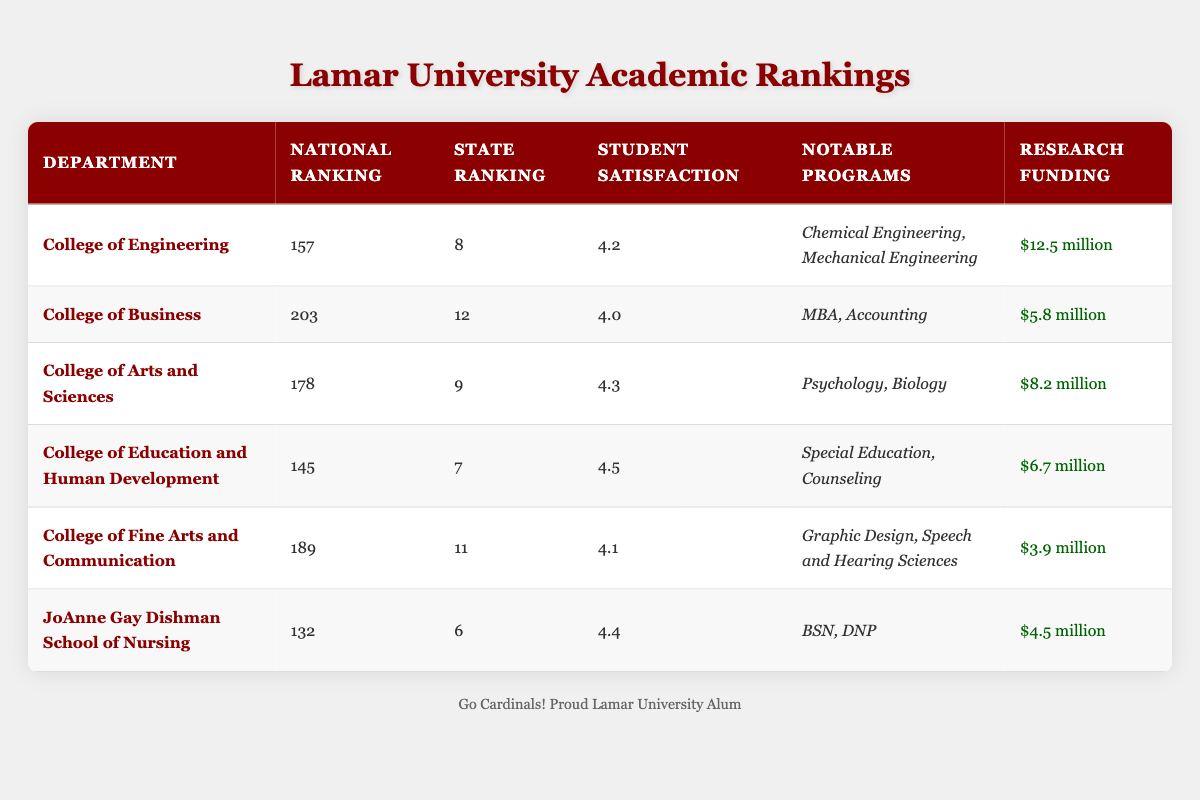What is the national ranking of the College of Engineering? The national ranking of the College of Engineering is 157, as listed in the table.
Answer: 157 Which department has the highest student satisfaction rating? The College of Education and Human Development has the highest student satisfaction rating of 4.5.
Answer: 4.5 What is the average state ranking of all departments? To find the average state ranking, add all state rankings (8 + 12 + 9 + 7 + 11 + 6 = 53) and divide by the number of departments (6), which gives 53/6 = 8.83.
Answer: 8.83 Is the research funding for the College of Fine Arts and Communication more than $4 million? The research funding for the College of Fine Arts and Communication is $3.9 million, which is less than $4 million.
Answer: No Which department has the lowest national ranking and what is it? The department with the lowest national ranking is the College of Business with a ranking of 203.
Answer: 203 How much more research funding does the College of Engineering have compared to the JoAnne Gay Dishman School of Nursing? The College of Engineering has $12.5 million and the JoAnne Gay Dishman School of Nursing has $4.5 million. The difference is 12.5 - 4.5 = $8 million.
Answer: $8 million Are there more notable programs in the College of Arts and Sciences compared to the College of Business? The College of Arts and Sciences has 2 notable programs (Psychology, Biology) and the College of Business also has 2 notable programs (MBA, Accounting), so they have the same number.
Answer: No What is the student satisfaction rating of the JoAnne Gay Dishman School of Nursing? The student satisfaction rating for the JoAnne Gay Dishman School of Nursing is 4.4, as shown in the table.
Answer: 4.4 Which department is ranked 8th in the state and what is its national ranking? The College of Engineering is ranked 8th in the state with a national ranking of 157.
Answer: College of Engineering, 157 